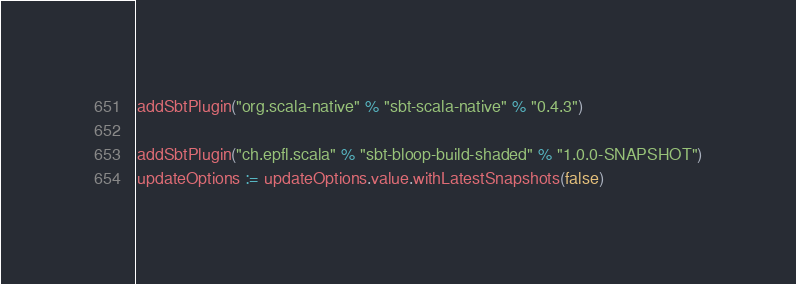Convert code to text. <code><loc_0><loc_0><loc_500><loc_500><_Scala_>addSbtPlugin("org.scala-native" % "sbt-scala-native" % "0.4.3")

addSbtPlugin("ch.epfl.scala" % "sbt-bloop-build-shaded" % "1.0.0-SNAPSHOT")
updateOptions := updateOptions.value.withLatestSnapshots(false)
</code> 